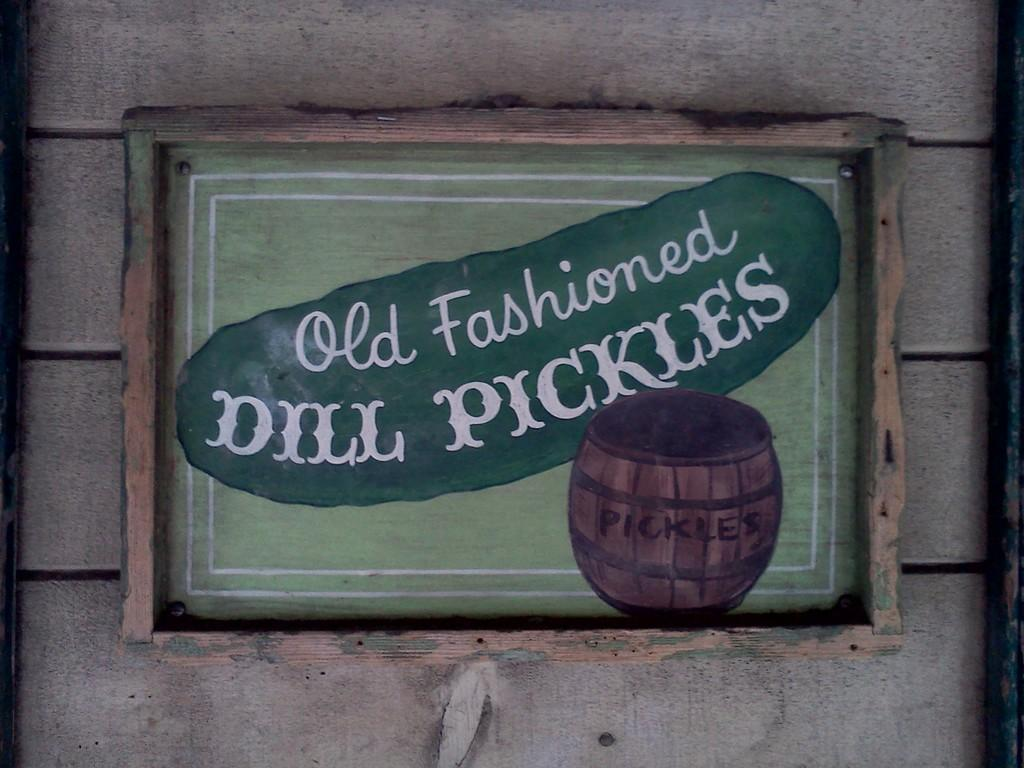What type of material is used for the wall in the image? The wall in the image is made of wood. What is hanging on the wooden wall? There is a poster on the wooden wall. What is depicted on the poster? The poster has a basket depicted on it. What text is written on the poster? The poster has the text "old fashioned dill pickles" written on it. Can you see any clouds in the image? There are no clouds visible in the image, as it focuses on a wooden wall and a poster. 